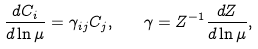<formula> <loc_0><loc_0><loc_500><loc_500>\frac { d C _ { i } } { d \ln \mu } = \gamma _ { i j } C _ { j } , \quad \gamma = Z ^ { - 1 } \frac { d Z } { d \ln \mu } ,</formula> 